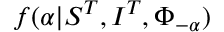Convert formula to latex. <formula><loc_0><loc_0><loc_500><loc_500>f ( \alpha | S ^ { T } , I ^ { T } , \Phi _ { - \alpha } )</formula> 